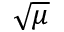<formula> <loc_0><loc_0><loc_500><loc_500>\sqrt { \mu }</formula> 